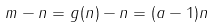Convert formula to latex. <formula><loc_0><loc_0><loc_500><loc_500>m - n = g ( n ) - n = ( a - 1 ) n</formula> 